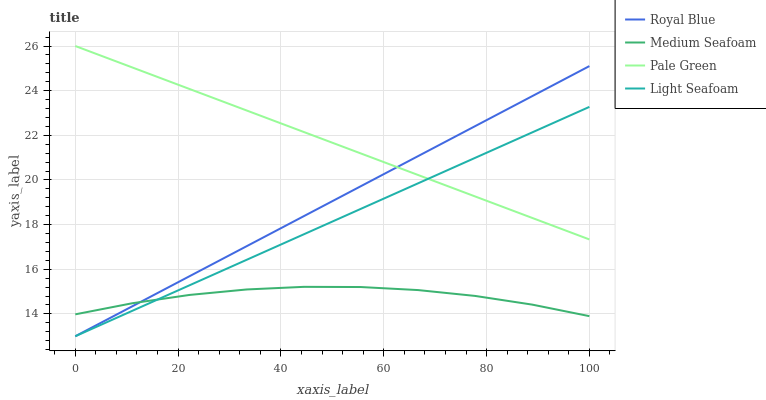Does Medium Seafoam have the minimum area under the curve?
Answer yes or no. Yes. Does Pale Green have the maximum area under the curve?
Answer yes or no. Yes. Does Pale Green have the minimum area under the curve?
Answer yes or no. No. Does Medium Seafoam have the maximum area under the curve?
Answer yes or no. No. Is Pale Green the smoothest?
Answer yes or no. Yes. Is Medium Seafoam the roughest?
Answer yes or no. Yes. Is Medium Seafoam the smoothest?
Answer yes or no. No. Is Pale Green the roughest?
Answer yes or no. No. Does Royal Blue have the lowest value?
Answer yes or no. Yes. Does Medium Seafoam have the lowest value?
Answer yes or no. No. Does Pale Green have the highest value?
Answer yes or no. Yes. Does Medium Seafoam have the highest value?
Answer yes or no. No. Is Medium Seafoam less than Pale Green?
Answer yes or no. Yes. Is Pale Green greater than Medium Seafoam?
Answer yes or no. Yes. Does Royal Blue intersect Pale Green?
Answer yes or no. Yes. Is Royal Blue less than Pale Green?
Answer yes or no. No. Is Royal Blue greater than Pale Green?
Answer yes or no. No. Does Medium Seafoam intersect Pale Green?
Answer yes or no. No. 